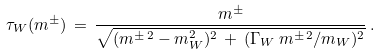Convert formula to latex. <formula><loc_0><loc_0><loc_500><loc_500>\tau _ { W } ( m ^ { \pm } ) \, = \, \frac { m ^ { \pm } } { \sqrt { ( m ^ { \pm \, 2 } - m _ { W } ^ { 2 } ) ^ { 2 } \, + \, ( \Gamma _ { W } \, m ^ { \pm \, 2 } / m _ { W } ) ^ { 2 } } } \, .</formula> 